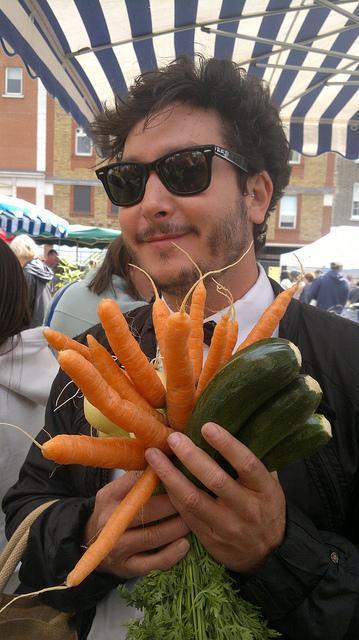How many people are in the photo?
Give a very brief answer. 3. How many carrots are there?
Give a very brief answer. 5. How many umbrellas are in the photo?
Give a very brief answer. 3. 